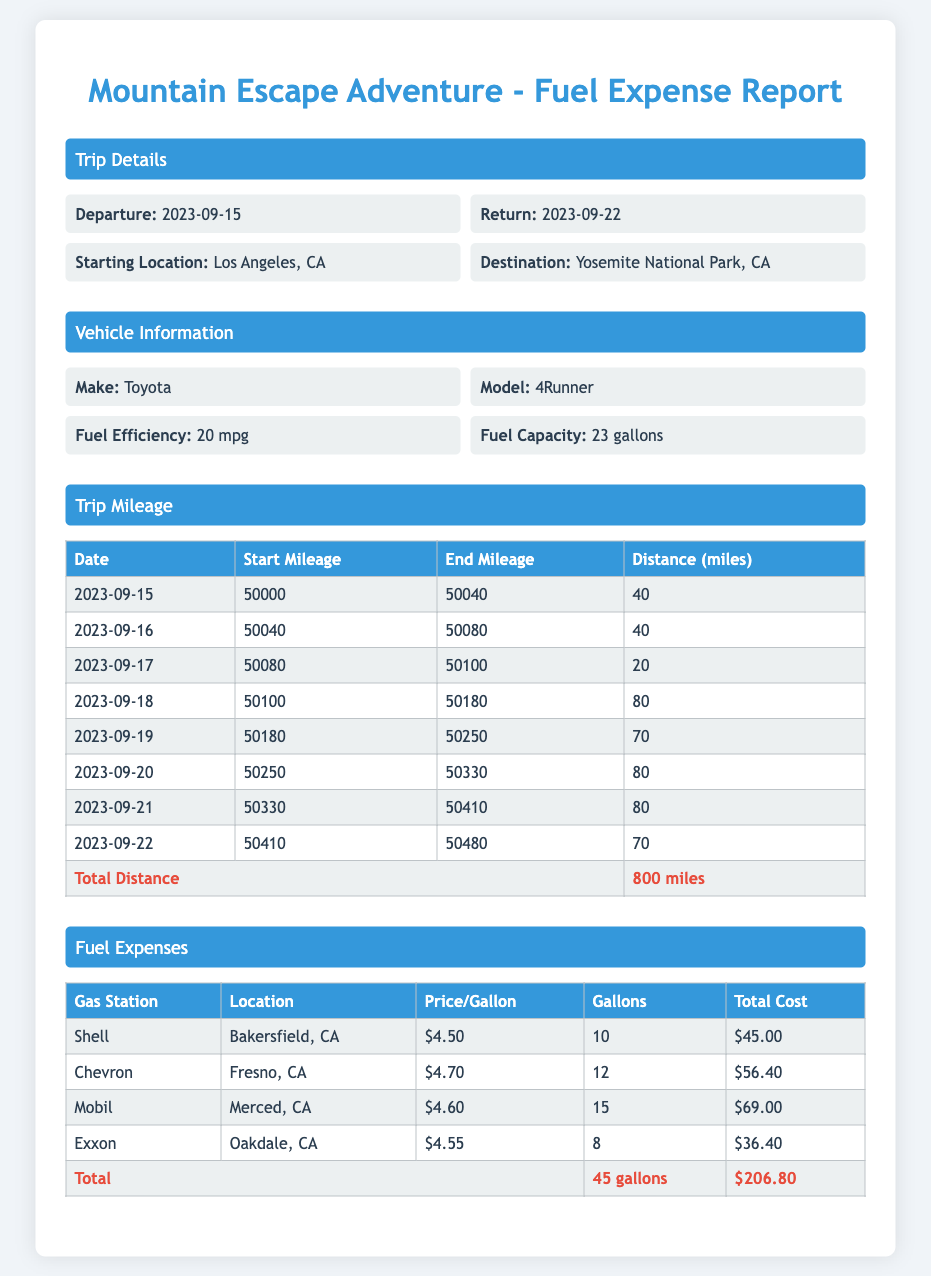What is the total distance traveled? The total distance is mentioned in the trip mileage section as 800 miles.
Answer: 800 miles What was the starting location of the trip? The starting location is specified in the trip details section as Los Angeles, CA.
Answer: Los Angeles, CA How many gallons of fuel were purchased at Chevron? The document states that 12 gallons were purchased at Chevron.
Answer: 12 gallons What is the price per gallon at Shell? The price per gallon at Shell is detailed in the fuel expenses section as $4.50.
Answer: $4.50 What date did the trip start? The trip start date is listed in the trip details section as 2023-09-15.
Answer: 2023-09-15 What was the total cost of fuel expenses? The total cost of fuel expenses is summed up in the fuel expenses section as $206.80.
Answer: $206.80 What is the vehicle's fuel efficiency? The vehicle's fuel efficiency is provided in the vehicle information section as 20 mpg.
Answer: 20 mpg Which gas station had the highest fuel price? The fuel price data shows that Chevron had the highest price at $4.70 per gallon.
Answer: Chevron How many gallons were filled at Mobil? The document specifies that 15 gallons were filled at Mobil.
Answer: 15 gallons 